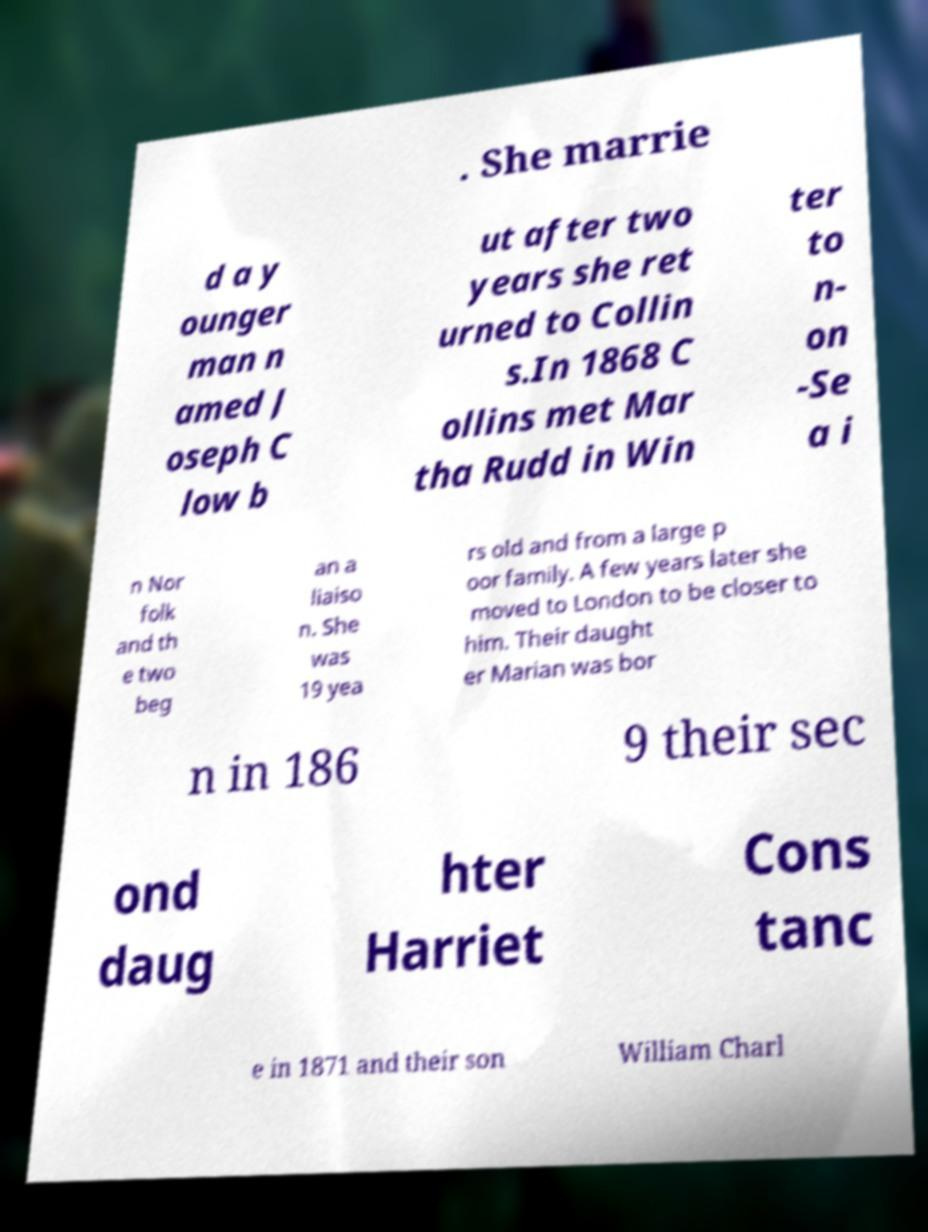What messages or text are displayed in this image? I need them in a readable, typed format. . She marrie d a y ounger man n amed J oseph C low b ut after two years she ret urned to Collin s.In 1868 C ollins met Mar tha Rudd in Win ter to n- on -Se a i n Nor folk and th e two beg an a liaiso n. She was 19 yea rs old and from a large p oor family. A few years later she moved to London to be closer to him. Their daught er Marian was bor n in 186 9 their sec ond daug hter Harriet Cons tanc e in 1871 and their son William Charl 